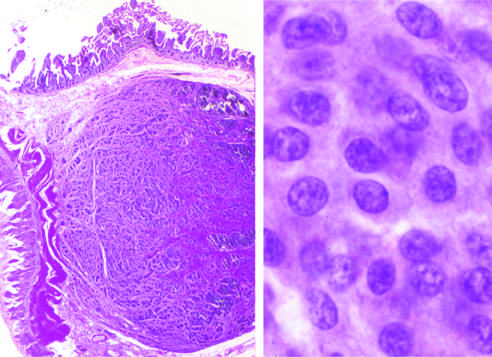do neutrophils assume a salt-and-pepper pattern?
Answer the question using a single word or phrase. No 